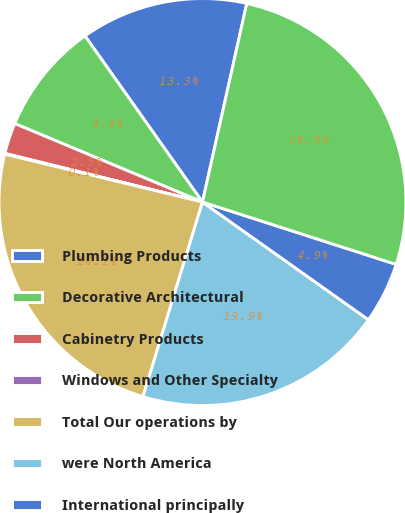<chart> <loc_0><loc_0><loc_500><loc_500><pie_chart><fcel>Plumbing Products<fcel>Decorative Architectural<fcel>Cabinetry Products<fcel>Windows and Other Specialty<fcel>Total Our operations by<fcel>were North America<fcel>International principally<fcel>Total as above<nl><fcel>13.29%<fcel>8.9%<fcel>2.46%<fcel>0.06%<fcel>24.06%<fcel>19.9%<fcel>4.86%<fcel>26.46%<nl></chart> 